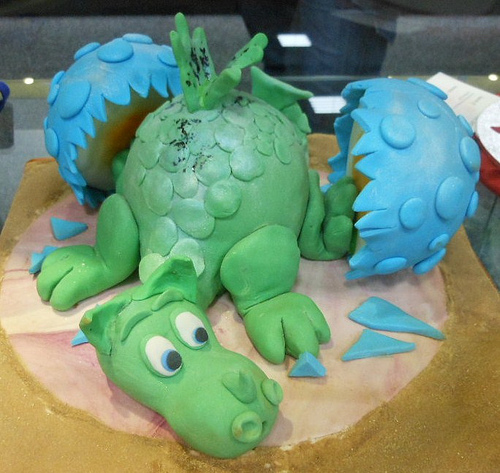<image>
Can you confirm if the dragon is behind the egg? No. The dragon is not behind the egg. From this viewpoint, the dragon appears to be positioned elsewhere in the scene. 